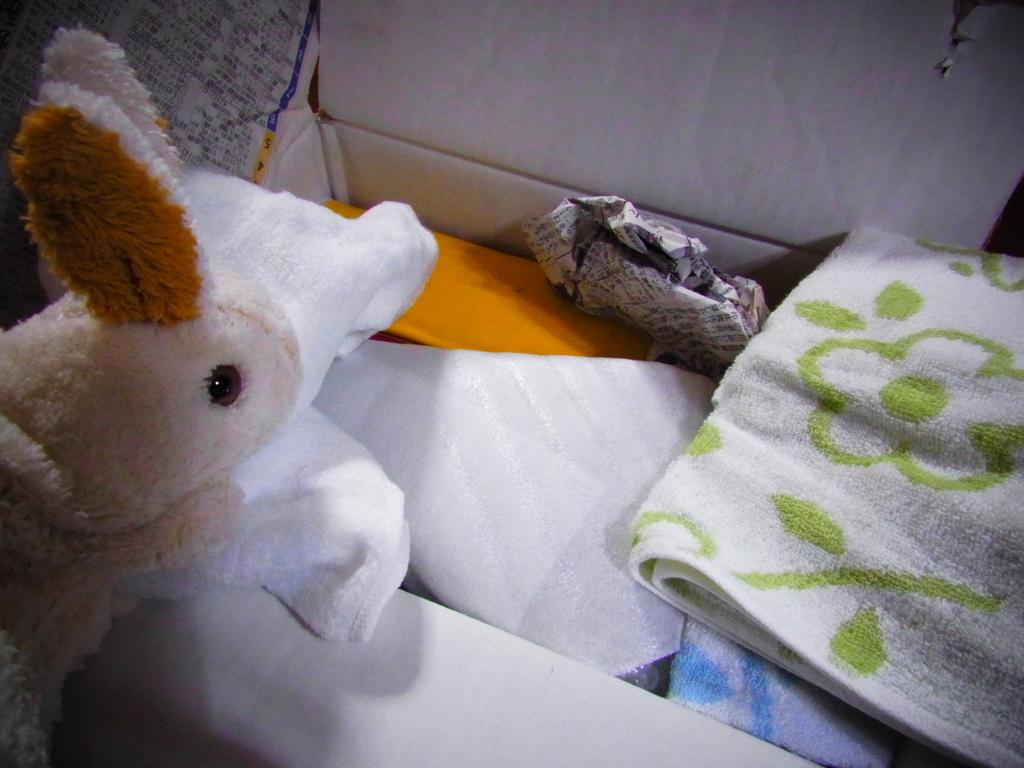What type of toy is in the image? There is a soft toy in the image. What else can be seen in the image besides the soft toy? There are clothes, a paper, and a white color box in the image. What is inside the white color box? There are other objects in the white color box. How many cherries are on the soft toy in the image? There are no cherries present in the image. What type of beef is being prepared in the image? There is no beef or any food preparation visible in the image. 